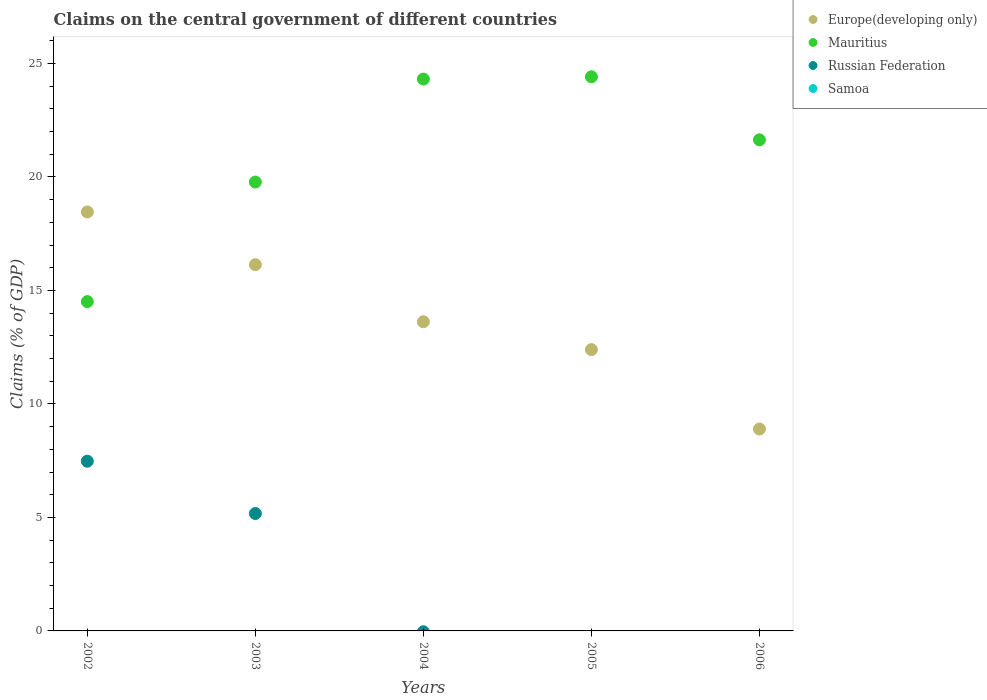How many different coloured dotlines are there?
Your answer should be very brief. 3. What is the percentage of GDP claimed on the central government in Europe(developing only) in 2004?
Keep it short and to the point. 13.62. Across all years, what is the maximum percentage of GDP claimed on the central government in Russian Federation?
Give a very brief answer. 7.48. Across all years, what is the minimum percentage of GDP claimed on the central government in Europe(developing only)?
Offer a terse response. 8.9. What is the total percentage of GDP claimed on the central government in Europe(developing only) in the graph?
Offer a very short reply. 69.5. What is the difference between the percentage of GDP claimed on the central government in Mauritius in 2002 and that in 2003?
Provide a succinct answer. -5.27. What is the difference between the percentage of GDP claimed on the central government in Samoa in 2006 and the percentage of GDP claimed on the central government in Russian Federation in 2002?
Provide a short and direct response. -7.48. What is the average percentage of GDP claimed on the central government in Mauritius per year?
Your answer should be compact. 20.93. In the year 2005, what is the difference between the percentage of GDP claimed on the central government in Europe(developing only) and percentage of GDP claimed on the central government in Mauritius?
Keep it short and to the point. -12.02. In how many years, is the percentage of GDP claimed on the central government in Samoa greater than 8 %?
Offer a terse response. 0. What is the ratio of the percentage of GDP claimed on the central government in Europe(developing only) in 2003 to that in 2004?
Ensure brevity in your answer.  1.18. Is the percentage of GDP claimed on the central government in Mauritius in 2003 less than that in 2004?
Offer a terse response. Yes. Is the difference between the percentage of GDP claimed on the central government in Europe(developing only) in 2004 and 2005 greater than the difference between the percentage of GDP claimed on the central government in Mauritius in 2004 and 2005?
Offer a very short reply. Yes. What is the difference between the highest and the second highest percentage of GDP claimed on the central government in Mauritius?
Your answer should be very brief. 0.1. What is the difference between the highest and the lowest percentage of GDP claimed on the central government in Mauritius?
Give a very brief answer. 9.91. In how many years, is the percentage of GDP claimed on the central government in Mauritius greater than the average percentage of GDP claimed on the central government in Mauritius taken over all years?
Make the answer very short. 3. Is it the case that in every year, the sum of the percentage of GDP claimed on the central government in Samoa and percentage of GDP claimed on the central government in Mauritius  is greater than the sum of percentage of GDP claimed on the central government in Europe(developing only) and percentage of GDP claimed on the central government in Russian Federation?
Give a very brief answer. No. Does the percentage of GDP claimed on the central government in Europe(developing only) monotonically increase over the years?
Provide a short and direct response. No. Is the percentage of GDP claimed on the central government in Russian Federation strictly greater than the percentage of GDP claimed on the central government in Samoa over the years?
Provide a short and direct response. No. Is the percentage of GDP claimed on the central government in Mauritius strictly less than the percentage of GDP claimed on the central government in Samoa over the years?
Keep it short and to the point. No. How many years are there in the graph?
Make the answer very short. 5. What is the difference between two consecutive major ticks on the Y-axis?
Make the answer very short. 5. Are the values on the major ticks of Y-axis written in scientific E-notation?
Your answer should be very brief. No. Does the graph contain any zero values?
Offer a very short reply. Yes. Where does the legend appear in the graph?
Provide a short and direct response. Top right. How many legend labels are there?
Your answer should be very brief. 4. What is the title of the graph?
Give a very brief answer. Claims on the central government of different countries. What is the label or title of the X-axis?
Offer a terse response. Years. What is the label or title of the Y-axis?
Your answer should be compact. Claims (% of GDP). What is the Claims (% of GDP) of Europe(developing only) in 2002?
Provide a succinct answer. 18.46. What is the Claims (% of GDP) in Mauritius in 2002?
Keep it short and to the point. 14.51. What is the Claims (% of GDP) in Russian Federation in 2002?
Ensure brevity in your answer.  7.48. What is the Claims (% of GDP) in Europe(developing only) in 2003?
Ensure brevity in your answer.  16.14. What is the Claims (% of GDP) in Mauritius in 2003?
Ensure brevity in your answer.  19.78. What is the Claims (% of GDP) in Russian Federation in 2003?
Your answer should be compact. 5.17. What is the Claims (% of GDP) in Europe(developing only) in 2004?
Make the answer very short. 13.62. What is the Claims (% of GDP) of Mauritius in 2004?
Ensure brevity in your answer.  24.31. What is the Claims (% of GDP) in Samoa in 2004?
Offer a terse response. 0. What is the Claims (% of GDP) of Europe(developing only) in 2005?
Your response must be concise. 12.39. What is the Claims (% of GDP) of Mauritius in 2005?
Make the answer very short. 24.41. What is the Claims (% of GDP) in Russian Federation in 2005?
Ensure brevity in your answer.  0. What is the Claims (% of GDP) in Europe(developing only) in 2006?
Your response must be concise. 8.9. What is the Claims (% of GDP) in Mauritius in 2006?
Provide a succinct answer. 21.64. What is the Claims (% of GDP) of Russian Federation in 2006?
Your response must be concise. 0. Across all years, what is the maximum Claims (% of GDP) of Europe(developing only)?
Your answer should be compact. 18.46. Across all years, what is the maximum Claims (% of GDP) in Mauritius?
Offer a very short reply. 24.41. Across all years, what is the maximum Claims (% of GDP) of Russian Federation?
Your answer should be compact. 7.48. Across all years, what is the minimum Claims (% of GDP) in Europe(developing only)?
Your answer should be compact. 8.9. Across all years, what is the minimum Claims (% of GDP) in Mauritius?
Make the answer very short. 14.51. Across all years, what is the minimum Claims (% of GDP) in Russian Federation?
Give a very brief answer. 0. What is the total Claims (% of GDP) of Europe(developing only) in the graph?
Your answer should be compact. 69.5. What is the total Claims (% of GDP) in Mauritius in the graph?
Offer a very short reply. 104.65. What is the total Claims (% of GDP) in Russian Federation in the graph?
Provide a short and direct response. 12.65. What is the total Claims (% of GDP) of Samoa in the graph?
Offer a very short reply. 0. What is the difference between the Claims (% of GDP) in Europe(developing only) in 2002 and that in 2003?
Offer a terse response. 2.32. What is the difference between the Claims (% of GDP) in Mauritius in 2002 and that in 2003?
Your answer should be compact. -5.27. What is the difference between the Claims (% of GDP) of Russian Federation in 2002 and that in 2003?
Ensure brevity in your answer.  2.3. What is the difference between the Claims (% of GDP) in Europe(developing only) in 2002 and that in 2004?
Your answer should be compact. 4.84. What is the difference between the Claims (% of GDP) of Mauritius in 2002 and that in 2004?
Make the answer very short. -9.8. What is the difference between the Claims (% of GDP) in Europe(developing only) in 2002 and that in 2005?
Your answer should be compact. 6.06. What is the difference between the Claims (% of GDP) in Mauritius in 2002 and that in 2005?
Your answer should be very brief. -9.91. What is the difference between the Claims (% of GDP) in Europe(developing only) in 2002 and that in 2006?
Keep it short and to the point. 9.56. What is the difference between the Claims (% of GDP) in Mauritius in 2002 and that in 2006?
Offer a terse response. -7.13. What is the difference between the Claims (% of GDP) of Europe(developing only) in 2003 and that in 2004?
Make the answer very short. 2.51. What is the difference between the Claims (% of GDP) in Mauritius in 2003 and that in 2004?
Keep it short and to the point. -4.54. What is the difference between the Claims (% of GDP) in Europe(developing only) in 2003 and that in 2005?
Give a very brief answer. 3.74. What is the difference between the Claims (% of GDP) in Mauritius in 2003 and that in 2005?
Your answer should be very brief. -4.64. What is the difference between the Claims (% of GDP) in Europe(developing only) in 2003 and that in 2006?
Your response must be concise. 7.24. What is the difference between the Claims (% of GDP) of Mauritius in 2003 and that in 2006?
Keep it short and to the point. -1.86. What is the difference between the Claims (% of GDP) of Europe(developing only) in 2004 and that in 2005?
Offer a terse response. 1.23. What is the difference between the Claims (% of GDP) in Mauritius in 2004 and that in 2005?
Give a very brief answer. -0.1. What is the difference between the Claims (% of GDP) in Europe(developing only) in 2004 and that in 2006?
Provide a succinct answer. 4.73. What is the difference between the Claims (% of GDP) in Mauritius in 2004 and that in 2006?
Ensure brevity in your answer.  2.68. What is the difference between the Claims (% of GDP) of Europe(developing only) in 2005 and that in 2006?
Your answer should be compact. 3.5. What is the difference between the Claims (% of GDP) in Mauritius in 2005 and that in 2006?
Your answer should be very brief. 2.78. What is the difference between the Claims (% of GDP) of Europe(developing only) in 2002 and the Claims (% of GDP) of Mauritius in 2003?
Keep it short and to the point. -1.32. What is the difference between the Claims (% of GDP) in Europe(developing only) in 2002 and the Claims (% of GDP) in Russian Federation in 2003?
Provide a succinct answer. 13.29. What is the difference between the Claims (% of GDP) in Mauritius in 2002 and the Claims (% of GDP) in Russian Federation in 2003?
Offer a terse response. 9.34. What is the difference between the Claims (% of GDP) in Europe(developing only) in 2002 and the Claims (% of GDP) in Mauritius in 2004?
Give a very brief answer. -5.86. What is the difference between the Claims (% of GDP) in Europe(developing only) in 2002 and the Claims (% of GDP) in Mauritius in 2005?
Keep it short and to the point. -5.96. What is the difference between the Claims (% of GDP) in Europe(developing only) in 2002 and the Claims (% of GDP) in Mauritius in 2006?
Offer a very short reply. -3.18. What is the difference between the Claims (% of GDP) of Europe(developing only) in 2003 and the Claims (% of GDP) of Mauritius in 2004?
Your answer should be compact. -8.18. What is the difference between the Claims (% of GDP) of Europe(developing only) in 2003 and the Claims (% of GDP) of Mauritius in 2005?
Your answer should be compact. -8.28. What is the difference between the Claims (% of GDP) of Europe(developing only) in 2003 and the Claims (% of GDP) of Mauritius in 2006?
Your response must be concise. -5.5. What is the difference between the Claims (% of GDP) of Europe(developing only) in 2004 and the Claims (% of GDP) of Mauritius in 2005?
Make the answer very short. -10.79. What is the difference between the Claims (% of GDP) of Europe(developing only) in 2004 and the Claims (% of GDP) of Mauritius in 2006?
Give a very brief answer. -8.01. What is the difference between the Claims (% of GDP) of Europe(developing only) in 2005 and the Claims (% of GDP) of Mauritius in 2006?
Provide a short and direct response. -9.24. What is the average Claims (% of GDP) of Europe(developing only) per year?
Give a very brief answer. 13.9. What is the average Claims (% of GDP) of Mauritius per year?
Your response must be concise. 20.93. What is the average Claims (% of GDP) of Russian Federation per year?
Keep it short and to the point. 2.53. What is the average Claims (% of GDP) of Samoa per year?
Provide a succinct answer. 0. In the year 2002, what is the difference between the Claims (% of GDP) of Europe(developing only) and Claims (% of GDP) of Mauritius?
Provide a succinct answer. 3.95. In the year 2002, what is the difference between the Claims (% of GDP) in Europe(developing only) and Claims (% of GDP) in Russian Federation?
Your answer should be compact. 10.98. In the year 2002, what is the difference between the Claims (% of GDP) in Mauritius and Claims (% of GDP) in Russian Federation?
Give a very brief answer. 7.03. In the year 2003, what is the difference between the Claims (% of GDP) of Europe(developing only) and Claims (% of GDP) of Mauritius?
Make the answer very short. -3.64. In the year 2003, what is the difference between the Claims (% of GDP) of Europe(developing only) and Claims (% of GDP) of Russian Federation?
Your response must be concise. 10.96. In the year 2003, what is the difference between the Claims (% of GDP) of Mauritius and Claims (% of GDP) of Russian Federation?
Ensure brevity in your answer.  14.6. In the year 2004, what is the difference between the Claims (% of GDP) in Europe(developing only) and Claims (% of GDP) in Mauritius?
Your response must be concise. -10.69. In the year 2005, what is the difference between the Claims (% of GDP) in Europe(developing only) and Claims (% of GDP) in Mauritius?
Give a very brief answer. -12.02. In the year 2006, what is the difference between the Claims (% of GDP) of Europe(developing only) and Claims (% of GDP) of Mauritius?
Your response must be concise. -12.74. What is the ratio of the Claims (% of GDP) in Europe(developing only) in 2002 to that in 2003?
Make the answer very short. 1.14. What is the ratio of the Claims (% of GDP) of Mauritius in 2002 to that in 2003?
Provide a short and direct response. 0.73. What is the ratio of the Claims (% of GDP) in Russian Federation in 2002 to that in 2003?
Offer a terse response. 1.45. What is the ratio of the Claims (% of GDP) in Europe(developing only) in 2002 to that in 2004?
Your answer should be very brief. 1.36. What is the ratio of the Claims (% of GDP) in Mauritius in 2002 to that in 2004?
Offer a very short reply. 0.6. What is the ratio of the Claims (% of GDP) in Europe(developing only) in 2002 to that in 2005?
Offer a very short reply. 1.49. What is the ratio of the Claims (% of GDP) of Mauritius in 2002 to that in 2005?
Your answer should be very brief. 0.59. What is the ratio of the Claims (% of GDP) of Europe(developing only) in 2002 to that in 2006?
Provide a succinct answer. 2.07. What is the ratio of the Claims (% of GDP) in Mauritius in 2002 to that in 2006?
Your response must be concise. 0.67. What is the ratio of the Claims (% of GDP) of Europe(developing only) in 2003 to that in 2004?
Make the answer very short. 1.18. What is the ratio of the Claims (% of GDP) of Mauritius in 2003 to that in 2004?
Offer a terse response. 0.81. What is the ratio of the Claims (% of GDP) of Europe(developing only) in 2003 to that in 2005?
Your answer should be very brief. 1.3. What is the ratio of the Claims (% of GDP) of Mauritius in 2003 to that in 2005?
Ensure brevity in your answer.  0.81. What is the ratio of the Claims (% of GDP) of Europe(developing only) in 2003 to that in 2006?
Offer a very short reply. 1.81. What is the ratio of the Claims (% of GDP) of Mauritius in 2003 to that in 2006?
Your answer should be compact. 0.91. What is the ratio of the Claims (% of GDP) in Europe(developing only) in 2004 to that in 2005?
Keep it short and to the point. 1.1. What is the ratio of the Claims (% of GDP) of Mauritius in 2004 to that in 2005?
Provide a short and direct response. 1. What is the ratio of the Claims (% of GDP) of Europe(developing only) in 2004 to that in 2006?
Offer a very short reply. 1.53. What is the ratio of the Claims (% of GDP) of Mauritius in 2004 to that in 2006?
Provide a short and direct response. 1.12. What is the ratio of the Claims (% of GDP) in Europe(developing only) in 2005 to that in 2006?
Keep it short and to the point. 1.39. What is the ratio of the Claims (% of GDP) in Mauritius in 2005 to that in 2006?
Offer a terse response. 1.13. What is the difference between the highest and the second highest Claims (% of GDP) in Europe(developing only)?
Offer a terse response. 2.32. What is the difference between the highest and the second highest Claims (% of GDP) in Mauritius?
Provide a short and direct response. 0.1. What is the difference between the highest and the lowest Claims (% of GDP) of Europe(developing only)?
Make the answer very short. 9.56. What is the difference between the highest and the lowest Claims (% of GDP) in Mauritius?
Your response must be concise. 9.91. What is the difference between the highest and the lowest Claims (% of GDP) of Russian Federation?
Your answer should be compact. 7.48. 